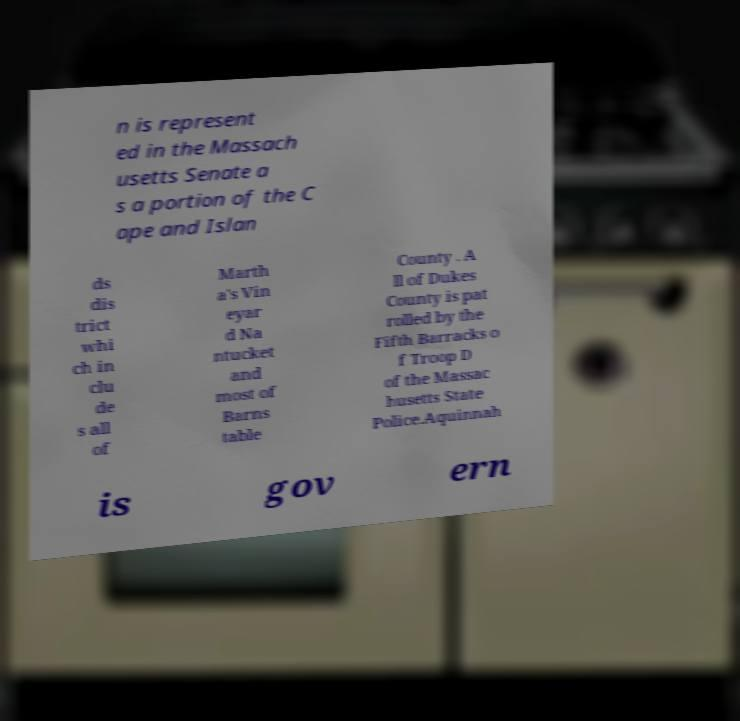Could you extract and type out the text from this image? n is represent ed in the Massach usetts Senate a s a portion of the C ape and Islan ds dis trict whi ch in clu de s all of Marth a's Vin eyar d Na ntucket and most of Barns table County . A ll of Dukes County is pat rolled by the Fifth Barracks o f Troop D of the Massac husetts State Police.Aquinnah is gov ern 